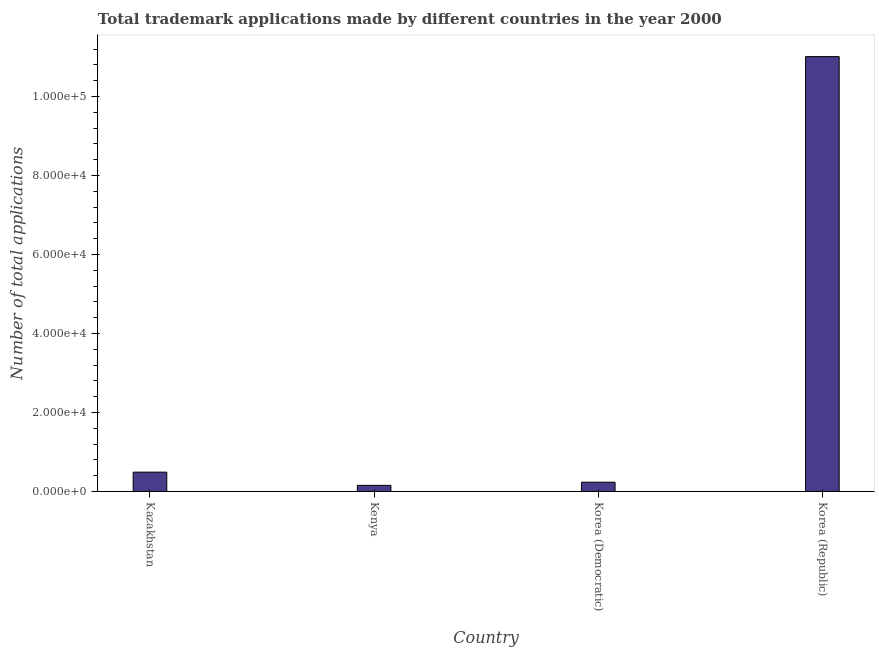What is the title of the graph?
Make the answer very short. Total trademark applications made by different countries in the year 2000. What is the label or title of the X-axis?
Ensure brevity in your answer.  Country. What is the label or title of the Y-axis?
Offer a terse response. Number of total applications. What is the number of trademark applications in Kazakhstan?
Your response must be concise. 4891. Across all countries, what is the maximum number of trademark applications?
Your answer should be compact. 1.10e+05. Across all countries, what is the minimum number of trademark applications?
Provide a short and direct response. 1548. In which country was the number of trademark applications minimum?
Ensure brevity in your answer.  Kenya. What is the sum of the number of trademark applications?
Your answer should be compact. 1.19e+05. What is the difference between the number of trademark applications in Kenya and Korea (Democratic)?
Your response must be concise. -800. What is the average number of trademark applications per country?
Ensure brevity in your answer.  2.97e+04. What is the median number of trademark applications?
Give a very brief answer. 3619.5. In how many countries, is the number of trademark applications greater than 88000 ?
Your answer should be compact. 1. What is the ratio of the number of trademark applications in Kazakhstan to that in Korea (Republic)?
Keep it short and to the point. 0.04. Is the number of trademark applications in Kenya less than that in Korea (Republic)?
Your response must be concise. Yes. Is the difference between the number of trademark applications in Kazakhstan and Korea (Republic) greater than the difference between any two countries?
Provide a short and direct response. No. What is the difference between the highest and the second highest number of trademark applications?
Offer a very short reply. 1.05e+05. Is the sum of the number of trademark applications in Kenya and Korea (Republic) greater than the maximum number of trademark applications across all countries?
Offer a very short reply. Yes. What is the difference between the highest and the lowest number of trademark applications?
Make the answer very short. 1.09e+05. In how many countries, is the number of trademark applications greater than the average number of trademark applications taken over all countries?
Your response must be concise. 1. How many bars are there?
Provide a succinct answer. 4. Are all the bars in the graph horizontal?
Ensure brevity in your answer.  No. How many countries are there in the graph?
Offer a terse response. 4. Are the values on the major ticks of Y-axis written in scientific E-notation?
Provide a short and direct response. Yes. What is the Number of total applications in Kazakhstan?
Make the answer very short. 4891. What is the Number of total applications of Kenya?
Keep it short and to the point. 1548. What is the Number of total applications in Korea (Democratic)?
Your answer should be very brief. 2348. What is the Number of total applications of Korea (Republic)?
Provide a short and direct response. 1.10e+05. What is the difference between the Number of total applications in Kazakhstan and Kenya?
Make the answer very short. 3343. What is the difference between the Number of total applications in Kazakhstan and Korea (Democratic)?
Provide a short and direct response. 2543. What is the difference between the Number of total applications in Kazakhstan and Korea (Republic)?
Make the answer very short. -1.05e+05. What is the difference between the Number of total applications in Kenya and Korea (Democratic)?
Your answer should be very brief. -800. What is the difference between the Number of total applications in Kenya and Korea (Republic)?
Your answer should be very brief. -1.09e+05. What is the difference between the Number of total applications in Korea (Democratic) and Korea (Republic)?
Your answer should be compact. -1.08e+05. What is the ratio of the Number of total applications in Kazakhstan to that in Kenya?
Give a very brief answer. 3.16. What is the ratio of the Number of total applications in Kazakhstan to that in Korea (Democratic)?
Your answer should be very brief. 2.08. What is the ratio of the Number of total applications in Kazakhstan to that in Korea (Republic)?
Provide a short and direct response. 0.04. What is the ratio of the Number of total applications in Kenya to that in Korea (Democratic)?
Your answer should be very brief. 0.66. What is the ratio of the Number of total applications in Kenya to that in Korea (Republic)?
Keep it short and to the point. 0.01. What is the ratio of the Number of total applications in Korea (Democratic) to that in Korea (Republic)?
Your answer should be very brief. 0.02. 